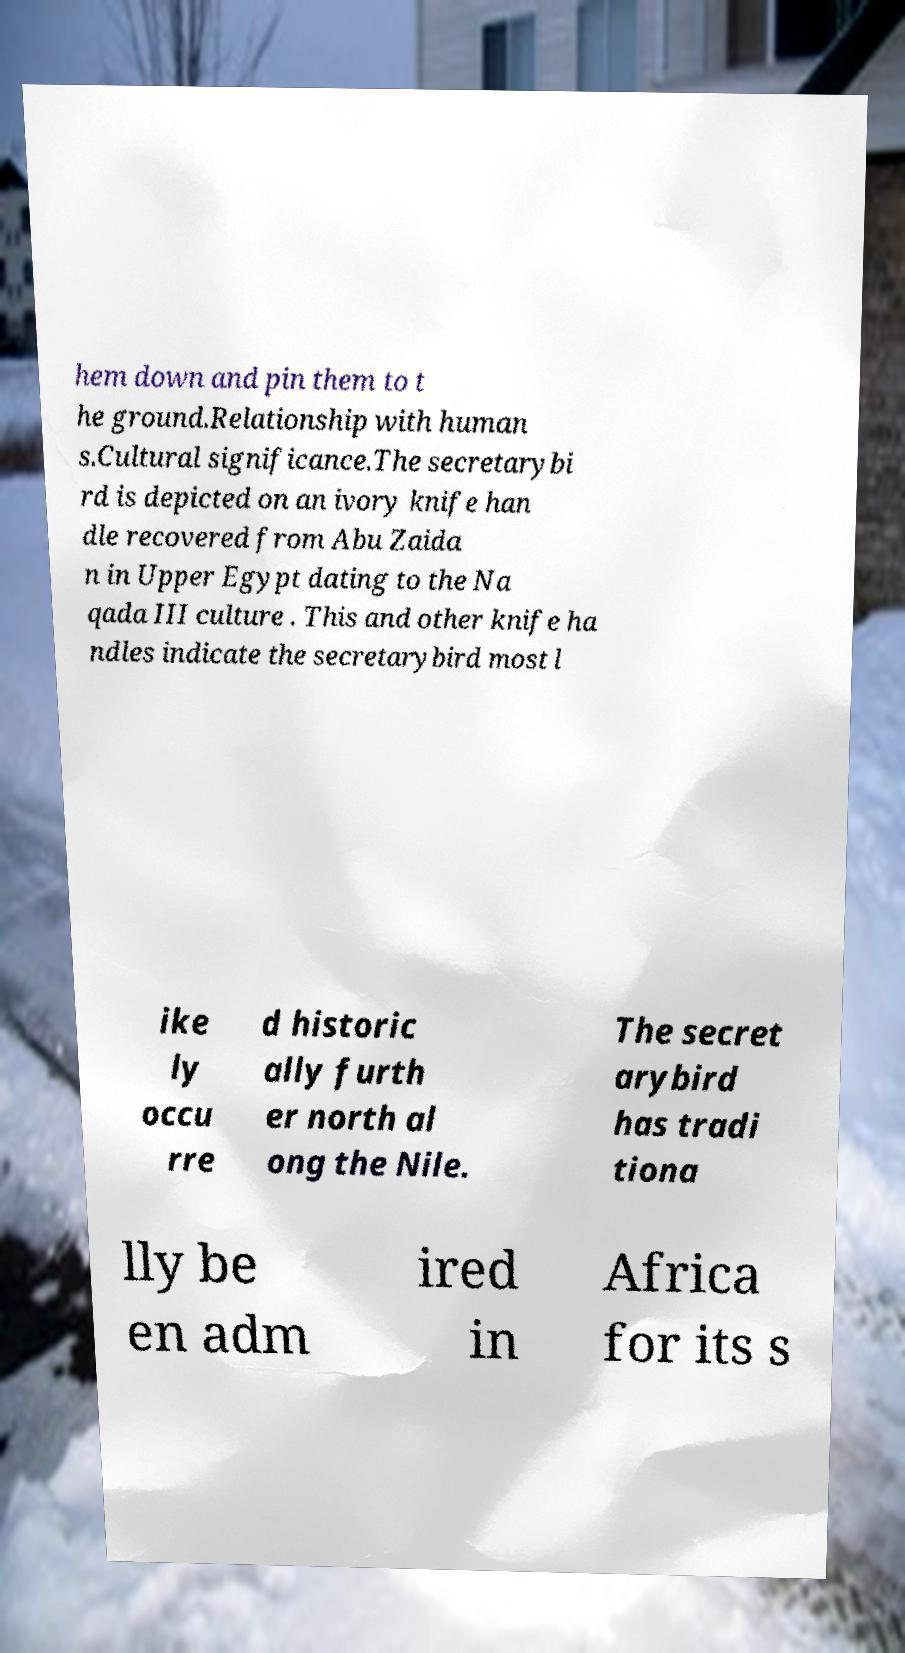Please read and relay the text visible in this image. What does it say? hem down and pin them to t he ground.Relationship with human s.Cultural significance.The secretarybi rd is depicted on an ivory knife han dle recovered from Abu Zaida n in Upper Egypt dating to the Na qada III culture . This and other knife ha ndles indicate the secretarybird most l ike ly occu rre d historic ally furth er north al ong the Nile. The secret arybird has tradi tiona lly be en adm ired in Africa for its s 